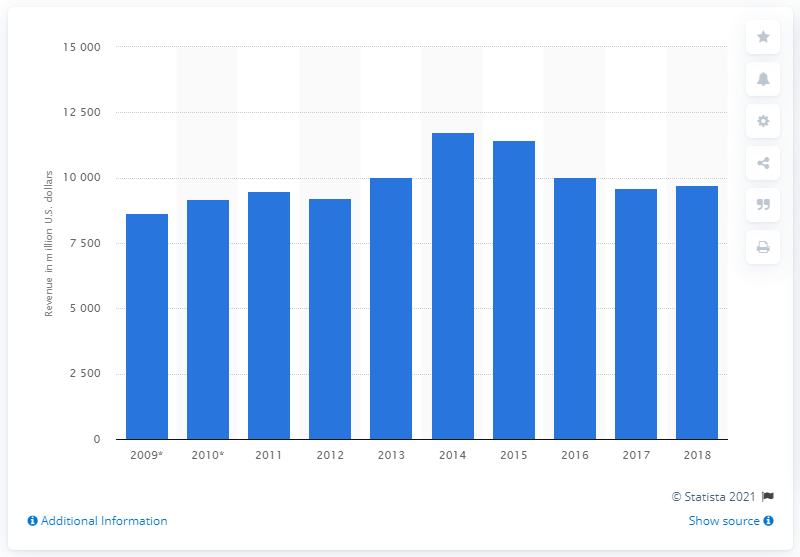Indicate a few pertinent items in this graphic. Ford's revenue in the United Kingdom in 2014 was 11,742. Ford's revenue in the UK in 2018 was 9,619. In 2015, Ford's revenue in the UK continued to decrease. Ford's revenue in the United States during the period of 2009 to 2013 was approximately 8661. 